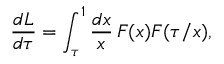Convert formula to latex. <formula><loc_0><loc_0><loc_500><loc_500>\frac { d L } { d \tau } = \int _ { \tau } ^ { 1 } \frac { d x } { x } \, F ( x ) F ( \tau / x ) ,</formula> 